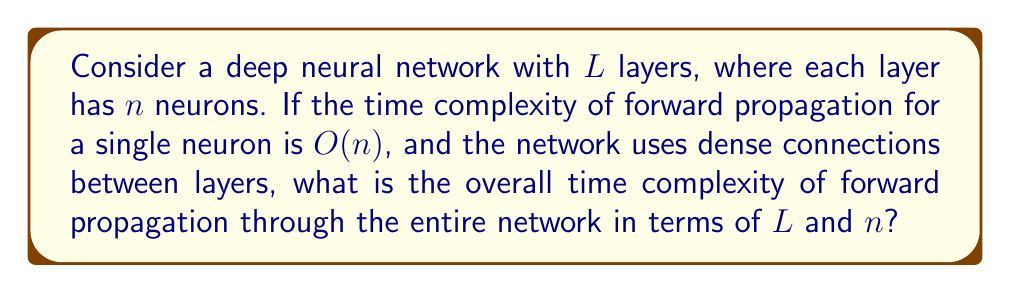Can you solve this math problem? To solve this problem, let's break it down step by step:

1. First, consider a single layer:
   - Each neuron in a layer receives input from all neurons in the previous layer.
   - There are $n$ neurons in each layer.
   - The time complexity for a single neuron is $O(n)$.
   - Therefore, the time complexity for one layer is $O(n) * n = O(n^2)$.

2. Now, consider the entire network:
   - There are $L$ layers in the network.
   - Each layer has a time complexity of $O(n^2)$.
   - We need to propagate through all $L$ layers.

3. To get the overall time complexity, we multiply the complexity of a single layer by the number of layers:
   $$O(n^2) * L = O(Ln^2)$$

4. This result, $O(Ln^2)$, represents the time complexity of forward propagation through the entire network.

5. In terms of hardware implementation, this complexity indicates that:
   - The computation time grows quadratically with the number of neurons per layer.
   - The computation time grows linearly with the number of layers.

This analysis is crucial for hardware design, as it helps in estimating the computational resources required for implementing deep learning algorithms in hardware, and can guide decisions on parallelization and memory management strategies.
Answer: $O(Ln^2)$ 